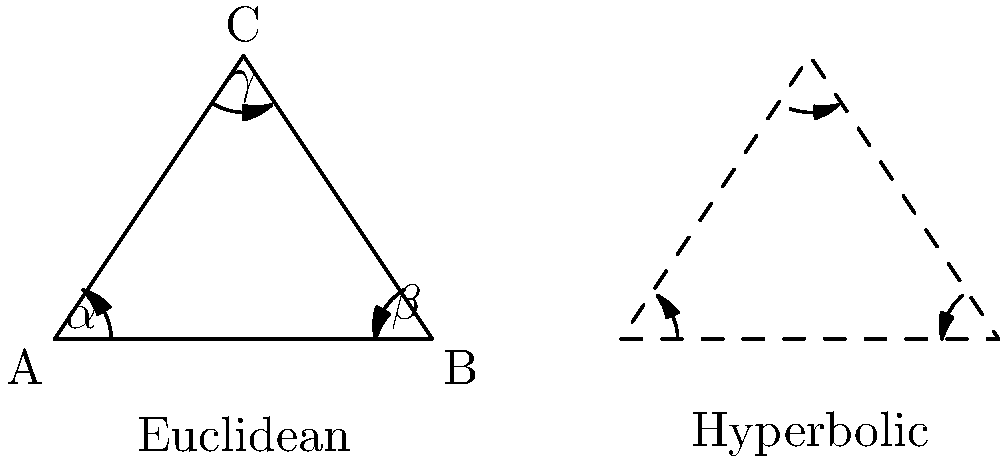In Euclidean geometry, the sum of angles in a triangle is always 180°. However, in hyperbolic geometry, this rule doesn't hold. Based on your knowledge of non-Euclidean geometry, how does the sum of angles in a hyperbolic triangle compare to that of a Euclidean triangle, and what does this imply about the nature of space in hyperbolic geometry? To understand the difference between Euclidean and hyperbolic triangles, let's break it down step-by-step:

1. Euclidean triangles:
   - In Euclidean geometry, the sum of angles in any triangle is always 180°.
   - This is represented by the equation: $\alpha + \beta + \gamma = 180°$

2. Hyperbolic triangles:
   - In hyperbolic geometry, the sum of angles in a triangle is always less than 180°.
   - This can be represented as: $\alpha + \beta + \gamma < 180°$

3. Angle defect:
   - The difference between 180° and the sum of angles in a hyperbolic triangle is called the angle defect.
   - Angle defect = $180° - (\alpha + \beta + \gamma)$

4. Implications for space:
   - The angle defect in hyperbolic geometry implies that space is curved negatively.
   - As triangles get larger in hyperbolic space, their angle sum decreases, approaching 0° for infinitely large triangles.

5. Comparison to spherical geometry:
   - In contrast, spherical geometry (another non-Euclidean geometry) has triangle angle sums greater than 180°.
   - This represents positively curved space, like the surface of a sphere.

6. Consistency of hyperbolic geometry:
   - The fact that hyperbolic triangles have angle sums less than 180° is consistent throughout hyperbolic space.
   - This property holds for all hyperbolic triangles, regardless of their size or location in the hyperbolic plane.

The difference in angle sums between Euclidean and hyperbolic triangles demonstrates that hyperbolic geometry describes a fundamentally different kind of space than the flat Euclidean plane we're accustomed to in everyday experience.
Answer: Sum of angles in hyperbolic triangle < 180°; implies negatively curved space 